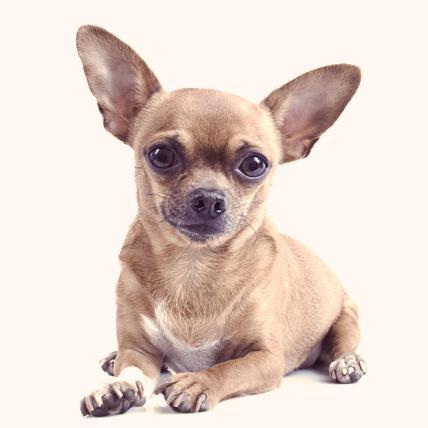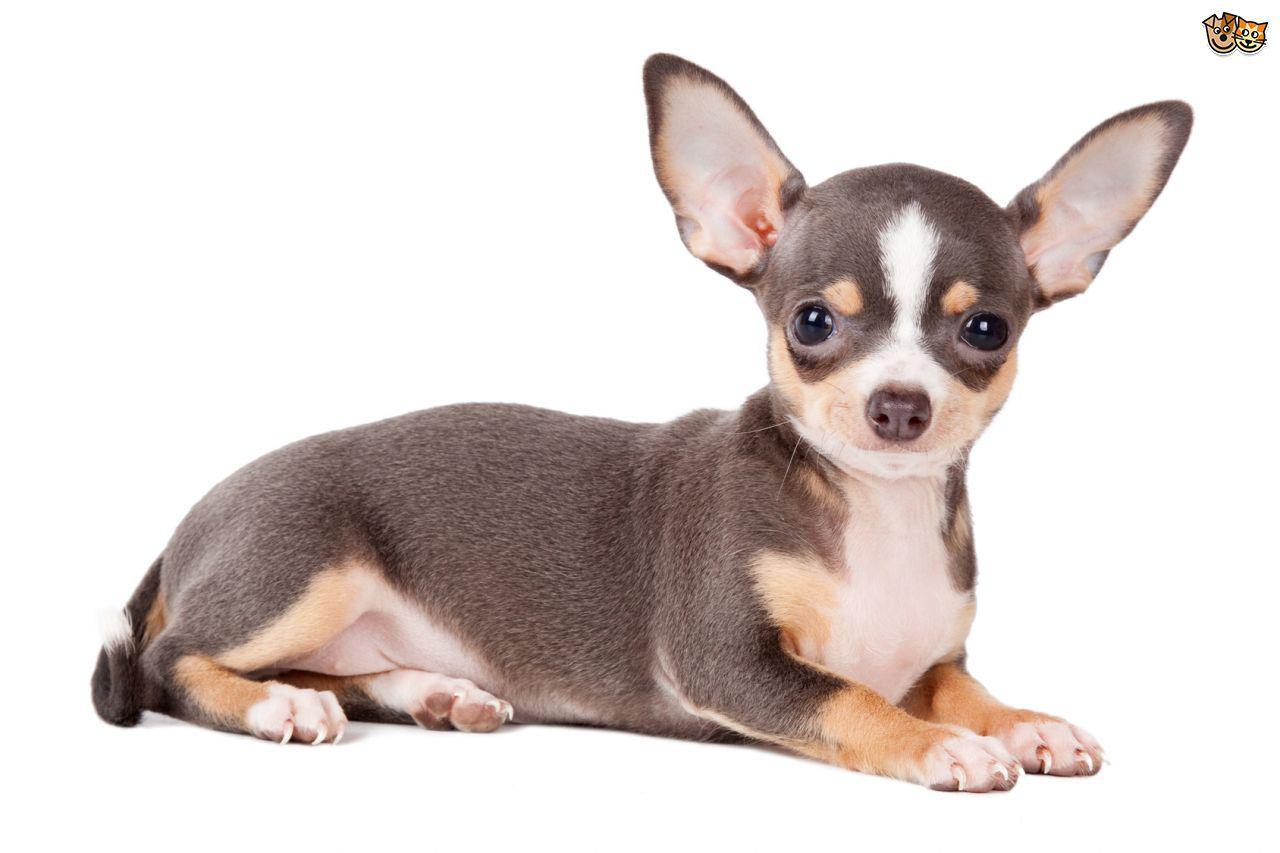The first image is the image on the left, the second image is the image on the right. Examine the images to the left and right. Is the description "At least one dog is wearing a collar." accurate? Answer yes or no. No. 